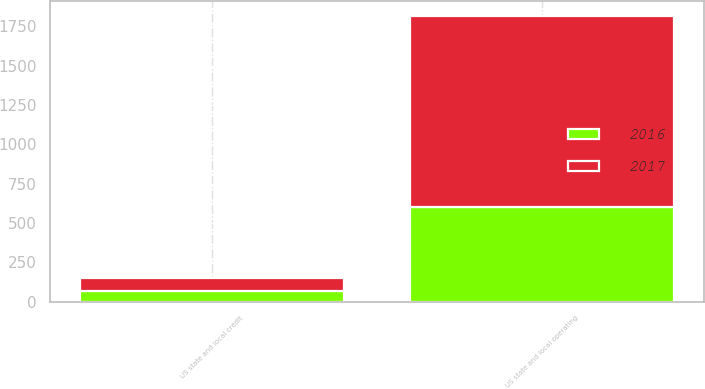Convert chart. <chart><loc_0><loc_0><loc_500><loc_500><stacked_bar_chart><ecel><fcel>US state and local operating<fcel>US state and local credit<nl><fcel>2017<fcel>1215<fcel>83<nl><fcel>2016<fcel>603<fcel>70<nl></chart> 